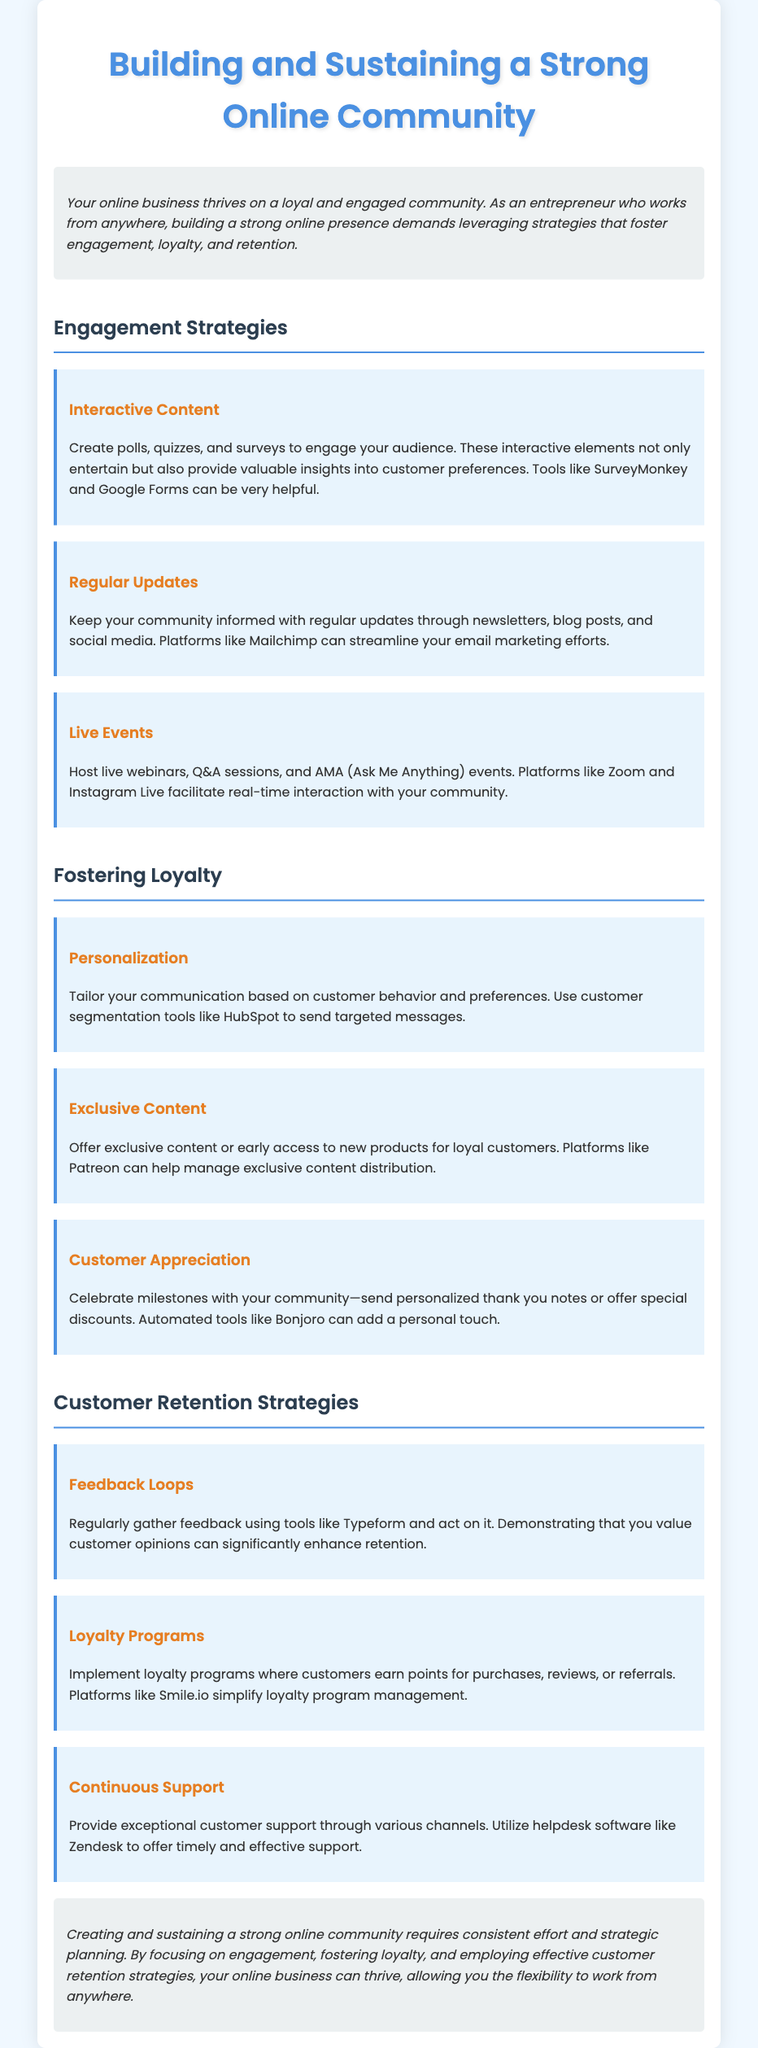What is the title of the document? The title is the main heading of the document, which introduces the topic discussed.
Answer: Building and Sustaining a Strong Online Community How many sections are there in the document? The document has three main sections: Engagement Strategies, Fostering Loyalty, and Customer Retention Strategies.
Answer: Three What tool can be used for creating surveys? The document mentions tools that can be used for engagement activities, including surveys.
Answer: SurveyMonkey What is one strategy to foster customer loyalty? The document provides several strategies under the section for fostering loyalty, specifically mentioned items contribute to loyalty.
Answer: Personalization What platform is recommended for loyalty program management? The document specifies a particular platform that helps in managing customer loyalty programs effectively.
Answer: Smile.io What type of events can strengthen community engagement? The document lists activities that involve direct interaction with the community, categorized as events that encourage participation.
Answer: Live webinars What should you send to celebrate milestones with your community? This activity is outlined as a way to show appreciation and strengthen bonds with customers.
Answer: Personalized thank you notes How should customer feedback be gathered? The document suggests specific tools and strategies for collecting customer opinions to improve services.
Answer: Regularly gather feedback using tools like Typeform What does the conclusion emphasize about community building? The conclusion summarizes the key points discussed throughout the document regarding the effort needed for community management.
Answer: Consistent effort and strategic planning 